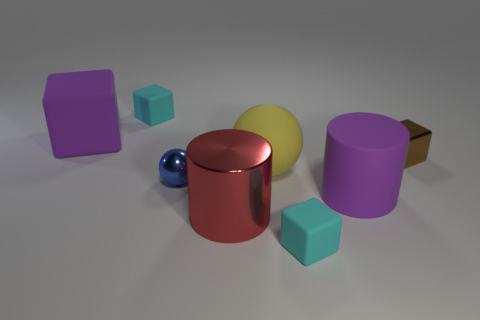What does the arrangement of these objects tell us about the scene? The objects are placed with some space between them on a flat surface, and they seem to be arranged somewhat randomly. The lighting and shadows suggest an indoor setting with a single light source, giving the scene a calm, studied appearance, as though it were a setup for a study of geometry or a 3D rendering test. 